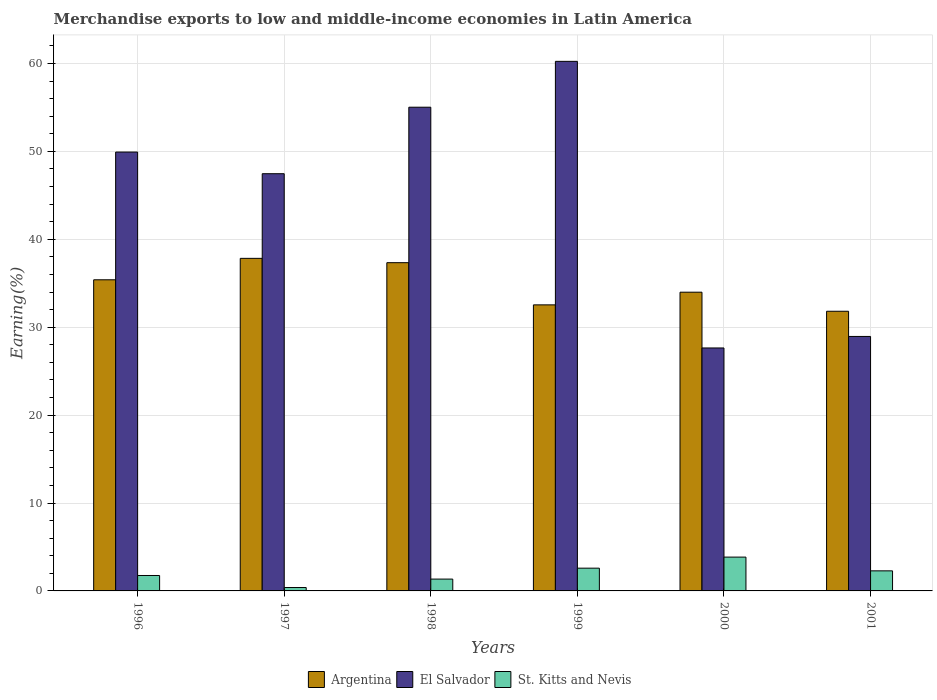Are the number of bars per tick equal to the number of legend labels?
Ensure brevity in your answer.  Yes. Are the number of bars on each tick of the X-axis equal?
Provide a short and direct response. Yes. How many bars are there on the 5th tick from the right?
Provide a short and direct response. 3. What is the label of the 4th group of bars from the left?
Provide a succinct answer. 1999. In how many cases, is the number of bars for a given year not equal to the number of legend labels?
Your response must be concise. 0. What is the percentage of amount earned from merchandise exports in El Salvador in 1996?
Provide a succinct answer. 49.92. Across all years, what is the maximum percentage of amount earned from merchandise exports in St. Kitts and Nevis?
Keep it short and to the point. 3.85. Across all years, what is the minimum percentage of amount earned from merchandise exports in St. Kitts and Nevis?
Ensure brevity in your answer.  0.39. In which year was the percentage of amount earned from merchandise exports in St. Kitts and Nevis minimum?
Provide a short and direct response. 1997. What is the total percentage of amount earned from merchandise exports in El Salvador in the graph?
Provide a succinct answer. 269.21. What is the difference between the percentage of amount earned from merchandise exports in El Salvador in 1997 and that in 1999?
Make the answer very short. -12.78. What is the difference between the percentage of amount earned from merchandise exports in Argentina in 1998 and the percentage of amount earned from merchandise exports in El Salvador in 1999?
Your answer should be compact. -22.9. What is the average percentage of amount earned from merchandise exports in St. Kitts and Nevis per year?
Provide a succinct answer. 2.03. In the year 1998, what is the difference between the percentage of amount earned from merchandise exports in St. Kitts and Nevis and percentage of amount earned from merchandise exports in Argentina?
Your answer should be compact. -35.99. What is the ratio of the percentage of amount earned from merchandise exports in El Salvador in 1999 to that in 2000?
Ensure brevity in your answer.  2.18. What is the difference between the highest and the second highest percentage of amount earned from merchandise exports in El Salvador?
Your answer should be very brief. 5.22. What is the difference between the highest and the lowest percentage of amount earned from merchandise exports in St. Kitts and Nevis?
Your answer should be compact. 3.46. Is the sum of the percentage of amount earned from merchandise exports in St. Kitts and Nevis in 1996 and 1999 greater than the maximum percentage of amount earned from merchandise exports in Argentina across all years?
Provide a short and direct response. No. What does the 1st bar from the left in 1999 represents?
Ensure brevity in your answer.  Argentina. What does the 3rd bar from the right in 1997 represents?
Offer a terse response. Argentina. How many bars are there?
Give a very brief answer. 18. Are all the bars in the graph horizontal?
Provide a succinct answer. No. What is the difference between two consecutive major ticks on the Y-axis?
Provide a short and direct response. 10. Does the graph contain any zero values?
Give a very brief answer. No. How many legend labels are there?
Offer a terse response. 3. What is the title of the graph?
Offer a very short reply. Merchandise exports to low and middle-income economies in Latin America. What is the label or title of the X-axis?
Provide a short and direct response. Years. What is the label or title of the Y-axis?
Provide a short and direct response. Earning(%). What is the Earning(%) in Argentina in 1996?
Make the answer very short. 35.39. What is the Earning(%) of El Salvador in 1996?
Offer a very short reply. 49.92. What is the Earning(%) of St. Kitts and Nevis in 1996?
Give a very brief answer. 1.75. What is the Earning(%) of Argentina in 1997?
Your answer should be very brief. 37.83. What is the Earning(%) in El Salvador in 1997?
Give a very brief answer. 47.46. What is the Earning(%) of St. Kitts and Nevis in 1997?
Give a very brief answer. 0.39. What is the Earning(%) in Argentina in 1998?
Your answer should be compact. 37.34. What is the Earning(%) of El Salvador in 1998?
Make the answer very short. 55.02. What is the Earning(%) of St. Kitts and Nevis in 1998?
Provide a succinct answer. 1.35. What is the Earning(%) of Argentina in 1999?
Offer a very short reply. 32.54. What is the Earning(%) in El Salvador in 1999?
Provide a short and direct response. 60.24. What is the Earning(%) in St. Kitts and Nevis in 1999?
Offer a very short reply. 2.59. What is the Earning(%) of Argentina in 2000?
Provide a succinct answer. 33.98. What is the Earning(%) of El Salvador in 2000?
Your response must be concise. 27.64. What is the Earning(%) of St. Kitts and Nevis in 2000?
Keep it short and to the point. 3.85. What is the Earning(%) in Argentina in 2001?
Keep it short and to the point. 31.81. What is the Earning(%) in El Salvador in 2001?
Make the answer very short. 28.95. What is the Earning(%) in St. Kitts and Nevis in 2001?
Your response must be concise. 2.28. Across all years, what is the maximum Earning(%) of Argentina?
Your answer should be very brief. 37.83. Across all years, what is the maximum Earning(%) in El Salvador?
Provide a succinct answer. 60.24. Across all years, what is the maximum Earning(%) of St. Kitts and Nevis?
Give a very brief answer. 3.85. Across all years, what is the minimum Earning(%) of Argentina?
Your answer should be compact. 31.81. Across all years, what is the minimum Earning(%) in El Salvador?
Give a very brief answer. 27.64. Across all years, what is the minimum Earning(%) of St. Kitts and Nevis?
Make the answer very short. 0.39. What is the total Earning(%) in Argentina in the graph?
Your response must be concise. 208.88. What is the total Earning(%) of El Salvador in the graph?
Offer a very short reply. 269.21. What is the total Earning(%) of St. Kitts and Nevis in the graph?
Offer a very short reply. 12.2. What is the difference between the Earning(%) of Argentina in 1996 and that in 1997?
Your response must be concise. -2.44. What is the difference between the Earning(%) of El Salvador in 1996 and that in 1997?
Ensure brevity in your answer.  2.46. What is the difference between the Earning(%) of St. Kitts and Nevis in 1996 and that in 1997?
Ensure brevity in your answer.  1.37. What is the difference between the Earning(%) of Argentina in 1996 and that in 1998?
Ensure brevity in your answer.  -1.95. What is the difference between the Earning(%) in El Salvador in 1996 and that in 1998?
Provide a succinct answer. -5.1. What is the difference between the Earning(%) in St. Kitts and Nevis in 1996 and that in 1998?
Ensure brevity in your answer.  0.41. What is the difference between the Earning(%) of Argentina in 1996 and that in 1999?
Your answer should be compact. 2.85. What is the difference between the Earning(%) of El Salvador in 1996 and that in 1999?
Keep it short and to the point. -10.32. What is the difference between the Earning(%) in St. Kitts and Nevis in 1996 and that in 1999?
Provide a succinct answer. -0.83. What is the difference between the Earning(%) of Argentina in 1996 and that in 2000?
Your response must be concise. 1.41. What is the difference between the Earning(%) in El Salvador in 1996 and that in 2000?
Your answer should be compact. 22.28. What is the difference between the Earning(%) in St. Kitts and Nevis in 1996 and that in 2000?
Your answer should be very brief. -2.09. What is the difference between the Earning(%) of Argentina in 1996 and that in 2001?
Your answer should be compact. 3.58. What is the difference between the Earning(%) of El Salvador in 1996 and that in 2001?
Your response must be concise. 20.97. What is the difference between the Earning(%) of St. Kitts and Nevis in 1996 and that in 2001?
Keep it short and to the point. -0.53. What is the difference between the Earning(%) in Argentina in 1997 and that in 1998?
Provide a short and direct response. 0.49. What is the difference between the Earning(%) in El Salvador in 1997 and that in 1998?
Keep it short and to the point. -7.56. What is the difference between the Earning(%) of St. Kitts and Nevis in 1997 and that in 1998?
Provide a succinct answer. -0.96. What is the difference between the Earning(%) in Argentina in 1997 and that in 1999?
Your answer should be very brief. 5.29. What is the difference between the Earning(%) in El Salvador in 1997 and that in 1999?
Offer a terse response. -12.78. What is the difference between the Earning(%) of St. Kitts and Nevis in 1997 and that in 1999?
Offer a terse response. -2.2. What is the difference between the Earning(%) in Argentina in 1997 and that in 2000?
Your answer should be compact. 3.85. What is the difference between the Earning(%) in El Salvador in 1997 and that in 2000?
Your response must be concise. 19.82. What is the difference between the Earning(%) in St. Kitts and Nevis in 1997 and that in 2000?
Give a very brief answer. -3.46. What is the difference between the Earning(%) in Argentina in 1997 and that in 2001?
Provide a succinct answer. 6.02. What is the difference between the Earning(%) in El Salvador in 1997 and that in 2001?
Provide a succinct answer. 18.51. What is the difference between the Earning(%) in St. Kitts and Nevis in 1997 and that in 2001?
Provide a short and direct response. -1.9. What is the difference between the Earning(%) of Argentina in 1998 and that in 1999?
Keep it short and to the point. 4.8. What is the difference between the Earning(%) of El Salvador in 1998 and that in 1999?
Provide a short and direct response. -5.22. What is the difference between the Earning(%) of St. Kitts and Nevis in 1998 and that in 1999?
Offer a very short reply. -1.24. What is the difference between the Earning(%) of Argentina in 1998 and that in 2000?
Offer a terse response. 3.36. What is the difference between the Earning(%) in El Salvador in 1998 and that in 2000?
Ensure brevity in your answer.  27.38. What is the difference between the Earning(%) of St. Kitts and Nevis in 1998 and that in 2000?
Your answer should be very brief. -2.5. What is the difference between the Earning(%) of Argentina in 1998 and that in 2001?
Your response must be concise. 5.53. What is the difference between the Earning(%) in El Salvador in 1998 and that in 2001?
Offer a very short reply. 26.07. What is the difference between the Earning(%) of St. Kitts and Nevis in 1998 and that in 2001?
Your response must be concise. -0.94. What is the difference between the Earning(%) of Argentina in 1999 and that in 2000?
Make the answer very short. -1.44. What is the difference between the Earning(%) in El Salvador in 1999 and that in 2000?
Your answer should be very brief. 32.6. What is the difference between the Earning(%) in St. Kitts and Nevis in 1999 and that in 2000?
Your response must be concise. -1.26. What is the difference between the Earning(%) of Argentina in 1999 and that in 2001?
Your response must be concise. 0.73. What is the difference between the Earning(%) of El Salvador in 1999 and that in 2001?
Make the answer very short. 31.29. What is the difference between the Earning(%) in St. Kitts and Nevis in 1999 and that in 2001?
Give a very brief answer. 0.3. What is the difference between the Earning(%) of Argentina in 2000 and that in 2001?
Keep it short and to the point. 2.17. What is the difference between the Earning(%) in El Salvador in 2000 and that in 2001?
Provide a succinct answer. -1.31. What is the difference between the Earning(%) of St. Kitts and Nevis in 2000 and that in 2001?
Make the answer very short. 1.56. What is the difference between the Earning(%) in Argentina in 1996 and the Earning(%) in El Salvador in 1997?
Provide a short and direct response. -12.07. What is the difference between the Earning(%) in Argentina in 1996 and the Earning(%) in St. Kitts and Nevis in 1997?
Offer a terse response. 35. What is the difference between the Earning(%) of El Salvador in 1996 and the Earning(%) of St. Kitts and Nevis in 1997?
Provide a short and direct response. 49.53. What is the difference between the Earning(%) in Argentina in 1996 and the Earning(%) in El Salvador in 1998?
Make the answer very short. -19.63. What is the difference between the Earning(%) in Argentina in 1996 and the Earning(%) in St. Kitts and Nevis in 1998?
Your answer should be very brief. 34.04. What is the difference between the Earning(%) in El Salvador in 1996 and the Earning(%) in St. Kitts and Nevis in 1998?
Provide a short and direct response. 48.57. What is the difference between the Earning(%) of Argentina in 1996 and the Earning(%) of El Salvador in 1999?
Provide a short and direct response. -24.85. What is the difference between the Earning(%) in Argentina in 1996 and the Earning(%) in St. Kitts and Nevis in 1999?
Your answer should be very brief. 32.8. What is the difference between the Earning(%) of El Salvador in 1996 and the Earning(%) of St. Kitts and Nevis in 1999?
Give a very brief answer. 47.33. What is the difference between the Earning(%) in Argentina in 1996 and the Earning(%) in El Salvador in 2000?
Keep it short and to the point. 7.75. What is the difference between the Earning(%) in Argentina in 1996 and the Earning(%) in St. Kitts and Nevis in 2000?
Your answer should be compact. 31.54. What is the difference between the Earning(%) of El Salvador in 1996 and the Earning(%) of St. Kitts and Nevis in 2000?
Provide a succinct answer. 46.07. What is the difference between the Earning(%) in Argentina in 1996 and the Earning(%) in El Salvador in 2001?
Keep it short and to the point. 6.44. What is the difference between the Earning(%) of Argentina in 1996 and the Earning(%) of St. Kitts and Nevis in 2001?
Offer a terse response. 33.11. What is the difference between the Earning(%) in El Salvador in 1996 and the Earning(%) in St. Kitts and Nevis in 2001?
Make the answer very short. 47.64. What is the difference between the Earning(%) of Argentina in 1997 and the Earning(%) of El Salvador in 1998?
Ensure brevity in your answer.  -17.19. What is the difference between the Earning(%) in Argentina in 1997 and the Earning(%) in St. Kitts and Nevis in 1998?
Provide a succinct answer. 36.48. What is the difference between the Earning(%) in El Salvador in 1997 and the Earning(%) in St. Kitts and Nevis in 1998?
Your answer should be very brief. 46.11. What is the difference between the Earning(%) of Argentina in 1997 and the Earning(%) of El Salvador in 1999?
Keep it short and to the point. -22.41. What is the difference between the Earning(%) in Argentina in 1997 and the Earning(%) in St. Kitts and Nevis in 1999?
Your response must be concise. 35.24. What is the difference between the Earning(%) in El Salvador in 1997 and the Earning(%) in St. Kitts and Nevis in 1999?
Your answer should be very brief. 44.87. What is the difference between the Earning(%) in Argentina in 1997 and the Earning(%) in El Salvador in 2000?
Provide a succinct answer. 10.19. What is the difference between the Earning(%) of Argentina in 1997 and the Earning(%) of St. Kitts and Nevis in 2000?
Your answer should be compact. 33.98. What is the difference between the Earning(%) of El Salvador in 1997 and the Earning(%) of St. Kitts and Nevis in 2000?
Provide a short and direct response. 43.61. What is the difference between the Earning(%) of Argentina in 1997 and the Earning(%) of El Salvador in 2001?
Provide a short and direct response. 8.88. What is the difference between the Earning(%) in Argentina in 1997 and the Earning(%) in St. Kitts and Nevis in 2001?
Give a very brief answer. 35.55. What is the difference between the Earning(%) of El Salvador in 1997 and the Earning(%) of St. Kitts and Nevis in 2001?
Ensure brevity in your answer.  45.17. What is the difference between the Earning(%) of Argentina in 1998 and the Earning(%) of El Salvador in 1999?
Provide a short and direct response. -22.9. What is the difference between the Earning(%) in Argentina in 1998 and the Earning(%) in St. Kitts and Nevis in 1999?
Your response must be concise. 34.75. What is the difference between the Earning(%) in El Salvador in 1998 and the Earning(%) in St. Kitts and Nevis in 1999?
Your answer should be very brief. 52.43. What is the difference between the Earning(%) of Argentina in 1998 and the Earning(%) of El Salvador in 2000?
Your response must be concise. 9.7. What is the difference between the Earning(%) of Argentina in 1998 and the Earning(%) of St. Kitts and Nevis in 2000?
Offer a very short reply. 33.49. What is the difference between the Earning(%) in El Salvador in 1998 and the Earning(%) in St. Kitts and Nevis in 2000?
Give a very brief answer. 51.17. What is the difference between the Earning(%) of Argentina in 1998 and the Earning(%) of El Salvador in 2001?
Keep it short and to the point. 8.39. What is the difference between the Earning(%) in Argentina in 1998 and the Earning(%) in St. Kitts and Nevis in 2001?
Provide a succinct answer. 35.05. What is the difference between the Earning(%) in El Salvador in 1998 and the Earning(%) in St. Kitts and Nevis in 2001?
Your answer should be very brief. 52.74. What is the difference between the Earning(%) of Argentina in 1999 and the Earning(%) of El Salvador in 2000?
Give a very brief answer. 4.9. What is the difference between the Earning(%) in Argentina in 1999 and the Earning(%) in St. Kitts and Nevis in 2000?
Your answer should be compact. 28.69. What is the difference between the Earning(%) of El Salvador in 1999 and the Earning(%) of St. Kitts and Nevis in 2000?
Ensure brevity in your answer.  56.39. What is the difference between the Earning(%) of Argentina in 1999 and the Earning(%) of El Salvador in 2001?
Offer a terse response. 3.59. What is the difference between the Earning(%) of Argentina in 1999 and the Earning(%) of St. Kitts and Nevis in 2001?
Your response must be concise. 30.25. What is the difference between the Earning(%) in El Salvador in 1999 and the Earning(%) in St. Kitts and Nevis in 2001?
Offer a very short reply. 57.95. What is the difference between the Earning(%) of Argentina in 2000 and the Earning(%) of El Salvador in 2001?
Your response must be concise. 5.03. What is the difference between the Earning(%) in Argentina in 2000 and the Earning(%) in St. Kitts and Nevis in 2001?
Your response must be concise. 31.7. What is the difference between the Earning(%) in El Salvador in 2000 and the Earning(%) in St. Kitts and Nevis in 2001?
Your answer should be very brief. 25.35. What is the average Earning(%) in Argentina per year?
Your answer should be very brief. 34.81. What is the average Earning(%) of El Salvador per year?
Your answer should be very brief. 44.87. What is the average Earning(%) in St. Kitts and Nevis per year?
Ensure brevity in your answer.  2.03. In the year 1996, what is the difference between the Earning(%) of Argentina and Earning(%) of El Salvador?
Make the answer very short. -14.53. In the year 1996, what is the difference between the Earning(%) in Argentina and Earning(%) in St. Kitts and Nevis?
Offer a very short reply. 33.64. In the year 1996, what is the difference between the Earning(%) in El Salvador and Earning(%) in St. Kitts and Nevis?
Offer a terse response. 48.16. In the year 1997, what is the difference between the Earning(%) in Argentina and Earning(%) in El Salvador?
Your answer should be very brief. -9.63. In the year 1997, what is the difference between the Earning(%) in Argentina and Earning(%) in St. Kitts and Nevis?
Offer a very short reply. 37.44. In the year 1997, what is the difference between the Earning(%) of El Salvador and Earning(%) of St. Kitts and Nevis?
Make the answer very short. 47.07. In the year 1998, what is the difference between the Earning(%) in Argentina and Earning(%) in El Salvador?
Provide a short and direct response. -17.68. In the year 1998, what is the difference between the Earning(%) in Argentina and Earning(%) in St. Kitts and Nevis?
Your answer should be very brief. 35.99. In the year 1998, what is the difference between the Earning(%) in El Salvador and Earning(%) in St. Kitts and Nevis?
Offer a terse response. 53.67. In the year 1999, what is the difference between the Earning(%) of Argentina and Earning(%) of El Salvador?
Give a very brief answer. -27.7. In the year 1999, what is the difference between the Earning(%) of Argentina and Earning(%) of St. Kitts and Nevis?
Make the answer very short. 29.95. In the year 1999, what is the difference between the Earning(%) of El Salvador and Earning(%) of St. Kitts and Nevis?
Your response must be concise. 57.65. In the year 2000, what is the difference between the Earning(%) in Argentina and Earning(%) in El Salvador?
Ensure brevity in your answer.  6.34. In the year 2000, what is the difference between the Earning(%) of Argentina and Earning(%) of St. Kitts and Nevis?
Your answer should be very brief. 30.13. In the year 2000, what is the difference between the Earning(%) in El Salvador and Earning(%) in St. Kitts and Nevis?
Your response must be concise. 23.79. In the year 2001, what is the difference between the Earning(%) in Argentina and Earning(%) in El Salvador?
Offer a very short reply. 2.86. In the year 2001, what is the difference between the Earning(%) of Argentina and Earning(%) of St. Kitts and Nevis?
Your answer should be very brief. 29.53. In the year 2001, what is the difference between the Earning(%) of El Salvador and Earning(%) of St. Kitts and Nevis?
Your answer should be compact. 26.66. What is the ratio of the Earning(%) of Argentina in 1996 to that in 1997?
Your response must be concise. 0.94. What is the ratio of the Earning(%) of El Salvador in 1996 to that in 1997?
Provide a succinct answer. 1.05. What is the ratio of the Earning(%) in St. Kitts and Nevis in 1996 to that in 1997?
Offer a terse response. 4.54. What is the ratio of the Earning(%) of Argentina in 1996 to that in 1998?
Your response must be concise. 0.95. What is the ratio of the Earning(%) of El Salvador in 1996 to that in 1998?
Your answer should be compact. 0.91. What is the ratio of the Earning(%) of St. Kitts and Nevis in 1996 to that in 1998?
Provide a short and direct response. 1.3. What is the ratio of the Earning(%) in Argentina in 1996 to that in 1999?
Keep it short and to the point. 1.09. What is the ratio of the Earning(%) in El Salvador in 1996 to that in 1999?
Your answer should be very brief. 0.83. What is the ratio of the Earning(%) of St. Kitts and Nevis in 1996 to that in 1999?
Offer a terse response. 0.68. What is the ratio of the Earning(%) of Argentina in 1996 to that in 2000?
Offer a terse response. 1.04. What is the ratio of the Earning(%) in El Salvador in 1996 to that in 2000?
Make the answer very short. 1.81. What is the ratio of the Earning(%) in St. Kitts and Nevis in 1996 to that in 2000?
Make the answer very short. 0.46. What is the ratio of the Earning(%) of Argentina in 1996 to that in 2001?
Keep it short and to the point. 1.11. What is the ratio of the Earning(%) of El Salvador in 1996 to that in 2001?
Give a very brief answer. 1.72. What is the ratio of the Earning(%) of St. Kitts and Nevis in 1996 to that in 2001?
Provide a succinct answer. 0.77. What is the ratio of the Earning(%) of Argentina in 1997 to that in 1998?
Ensure brevity in your answer.  1.01. What is the ratio of the Earning(%) of El Salvador in 1997 to that in 1998?
Give a very brief answer. 0.86. What is the ratio of the Earning(%) of St. Kitts and Nevis in 1997 to that in 1998?
Give a very brief answer. 0.29. What is the ratio of the Earning(%) in Argentina in 1997 to that in 1999?
Ensure brevity in your answer.  1.16. What is the ratio of the Earning(%) in El Salvador in 1997 to that in 1999?
Keep it short and to the point. 0.79. What is the ratio of the Earning(%) in St. Kitts and Nevis in 1997 to that in 1999?
Make the answer very short. 0.15. What is the ratio of the Earning(%) of Argentina in 1997 to that in 2000?
Your answer should be compact. 1.11. What is the ratio of the Earning(%) in El Salvador in 1997 to that in 2000?
Your answer should be very brief. 1.72. What is the ratio of the Earning(%) of St. Kitts and Nevis in 1997 to that in 2000?
Give a very brief answer. 0.1. What is the ratio of the Earning(%) of Argentina in 1997 to that in 2001?
Offer a terse response. 1.19. What is the ratio of the Earning(%) in El Salvador in 1997 to that in 2001?
Your response must be concise. 1.64. What is the ratio of the Earning(%) in St. Kitts and Nevis in 1997 to that in 2001?
Keep it short and to the point. 0.17. What is the ratio of the Earning(%) in Argentina in 1998 to that in 1999?
Offer a terse response. 1.15. What is the ratio of the Earning(%) in El Salvador in 1998 to that in 1999?
Your response must be concise. 0.91. What is the ratio of the Earning(%) in St. Kitts and Nevis in 1998 to that in 1999?
Give a very brief answer. 0.52. What is the ratio of the Earning(%) in Argentina in 1998 to that in 2000?
Your answer should be very brief. 1.1. What is the ratio of the Earning(%) in El Salvador in 1998 to that in 2000?
Keep it short and to the point. 1.99. What is the ratio of the Earning(%) in St. Kitts and Nevis in 1998 to that in 2000?
Your answer should be very brief. 0.35. What is the ratio of the Earning(%) of Argentina in 1998 to that in 2001?
Provide a succinct answer. 1.17. What is the ratio of the Earning(%) in El Salvador in 1998 to that in 2001?
Your response must be concise. 1.9. What is the ratio of the Earning(%) of St. Kitts and Nevis in 1998 to that in 2001?
Provide a succinct answer. 0.59. What is the ratio of the Earning(%) of Argentina in 1999 to that in 2000?
Make the answer very short. 0.96. What is the ratio of the Earning(%) in El Salvador in 1999 to that in 2000?
Make the answer very short. 2.18. What is the ratio of the Earning(%) of St. Kitts and Nevis in 1999 to that in 2000?
Your answer should be very brief. 0.67. What is the ratio of the Earning(%) in Argentina in 1999 to that in 2001?
Provide a short and direct response. 1.02. What is the ratio of the Earning(%) in El Salvador in 1999 to that in 2001?
Provide a short and direct response. 2.08. What is the ratio of the Earning(%) in St. Kitts and Nevis in 1999 to that in 2001?
Give a very brief answer. 1.13. What is the ratio of the Earning(%) of Argentina in 2000 to that in 2001?
Offer a very short reply. 1.07. What is the ratio of the Earning(%) of El Salvador in 2000 to that in 2001?
Provide a succinct answer. 0.95. What is the ratio of the Earning(%) of St. Kitts and Nevis in 2000 to that in 2001?
Offer a very short reply. 1.68. What is the difference between the highest and the second highest Earning(%) in Argentina?
Your answer should be compact. 0.49. What is the difference between the highest and the second highest Earning(%) of El Salvador?
Your response must be concise. 5.22. What is the difference between the highest and the second highest Earning(%) of St. Kitts and Nevis?
Your answer should be very brief. 1.26. What is the difference between the highest and the lowest Earning(%) in Argentina?
Provide a succinct answer. 6.02. What is the difference between the highest and the lowest Earning(%) in El Salvador?
Make the answer very short. 32.6. What is the difference between the highest and the lowest Earning(%) of St. Kitts and Nevis?
Offer a terse response. 3.46. 